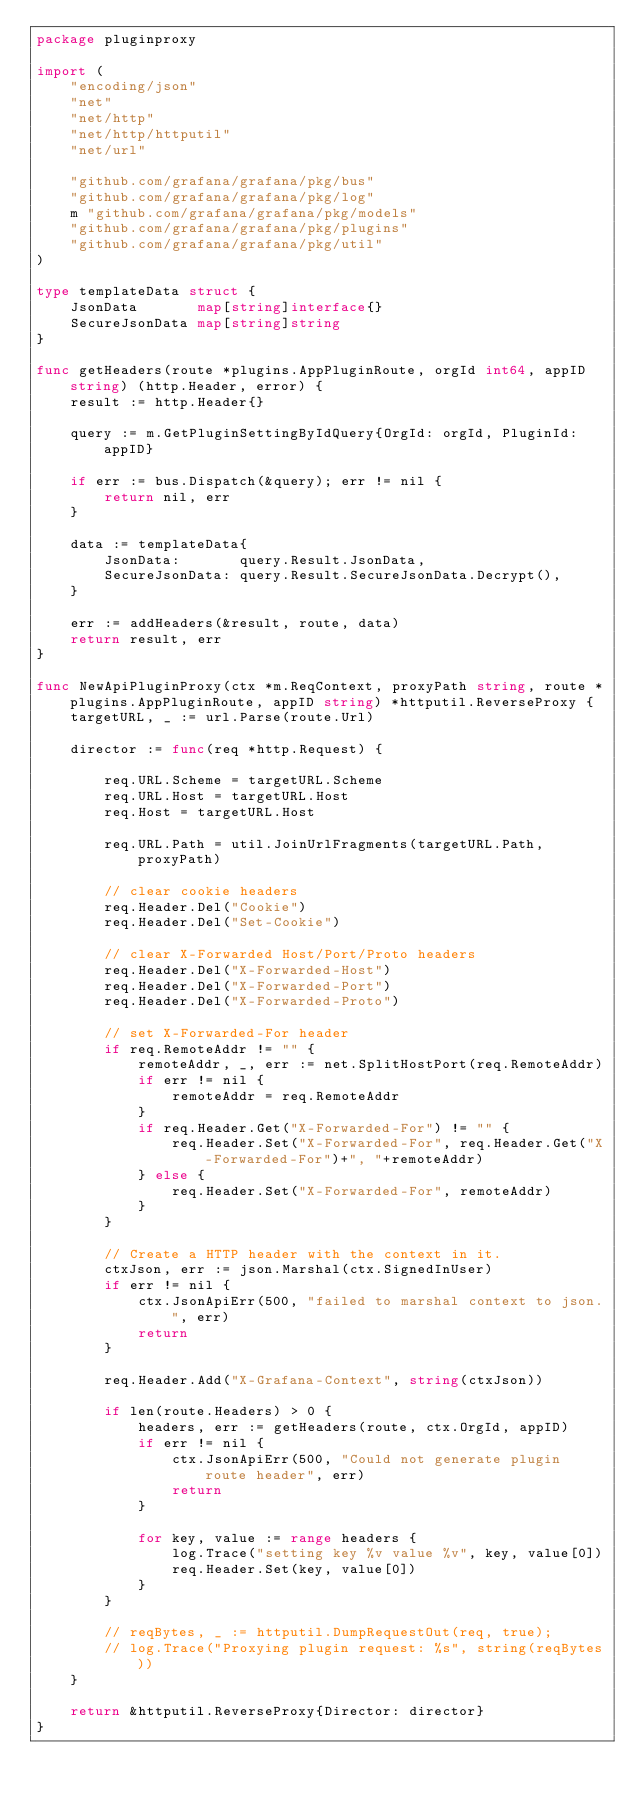<code> <loc_0><loc_0><loc_500><loc_500><_Go_>package pluginproxy

import (
	"encoding/json"
	"net"
	"net/http"
	"net/http/httputil"
	"net/url"

	"github.com/grafana/grafana/pkg/bus"
	"github.com/grafana/grafana/pkg/log"
	m "github.com/grafana/grafana/pkg/models"
	"github.com/grafana/grafana/pkg/plugins"
	"github.com/grafana/grafana/pkg/util"
)

type templateData struct {
	JsonData       map[string]interface{}
	SecureJsonData map[string]string
}

func getHeaders(route *plugins.AppPluginRoute, orgId int64, appID string) (http.Header, error) {
	result := http.Header{}

	query := m.GetPluginSettingByIdQuery{OrgId: orgId, PluginId: appID}

	if err := bus.Dispatch(&query); err != nil {
		return nil, err
	}

	data := templateData{
		JsonData:       query.Result.JsonData,
		SecureJsonData: query.Result.SecureJsonData.Decrypt(),
	}

	err := addHeaders(&result, route, data)
	return result, err
}

func NewApiPluginProxy(ctx *m.ReqContext, proxyPath string, route *plugins.AppPluginRoute, appID string) *httputil.ReverseProxy {
	targetURL, _ := url.Parse(route.Url)

	director := func(req *http.Request) {

		req.URL.Scheme = targetURL.Scheme
		req.URL.Host = targetURL.Host
		req.Host = targetURL.Host

		req.URL.Path = util.JoinUrlFragments(targetURL.Path, proxyPath)

		// clear cookie headers
		req.Header.Del("Cookie")
		req.Header.Del("Set-Cookie")

		// clear X-Forwarded Host/Port/Proto headers
		req.Header.Del("X-Forwarded-Host")
		req.Header.Del("X-Forwarded-Port")
		req.Header.Del("X-Forwarded-Proto")

		// set X-Forwarded-For header
		if req.RemoteAddr != "" {
			remoteAddr, _, err := net.SplitHostPort(req.RemoteAddr)
			if err != nil {
				remoteAddr = req.RemoteAddr
			}
			if req.Header.Get("X-Forwarded-For") != "" {
				req.Header.Set("X-Forwarded-For", req.Header.Get("X-Forwarded-For")+", "+remoteAddr)
			} else {
				req.Header.Set("X-Forwarded-For", remoteAddr)
			}
		}

		// Create a HTTP header with the context in it.
		ctxJson, err := json.Marshal(ctx.SignedInUser)
		if err != nil {
			ctx.JsonApiErr(500, "failed to marshal context to json.", err)
			return
		}

		req.Header.Add("X-Grafana-Context", string(ctxJson))

		if len(route.Headers) > 0 {
			headers, err := getHeaders(route, ctx.OrgId, appID)
			if err != nil {
				ctx.JsonApiErr(500, "Could not generate plugin route header", err)
				return
			}

			for key, value := range headers {
				log.Trace("setting key %v value %v", key, value[0])
				req.Header.Set(key, value[0])
			}
		}

		// reqBytes, _ := httputil.DumpRequestOut(req, true);
		// log.Trace("Proxying plugin request: %s", string(reqBytes))
	}

	return &httputil.ReverseProxy{Director: director}
}
</code> 